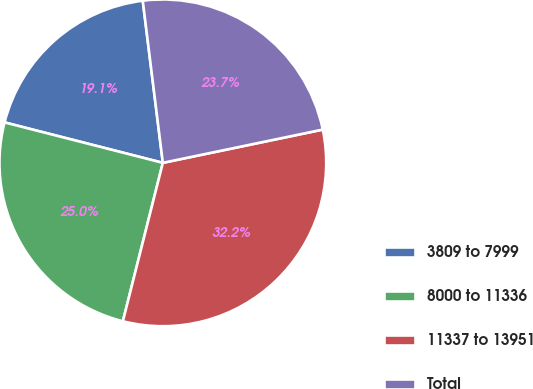Convert chart. <chart><loc_0><loc_0><loc_500><loc_500><pie_chart><fcel>3809 to 7999<fcel>8000 to 11336<fcel>11337 to 13951<fcel>Total<nl><fcel>19.06%<fcel>25.05%<fcel>32.2%<fcel>23.7%<nl></chart> 